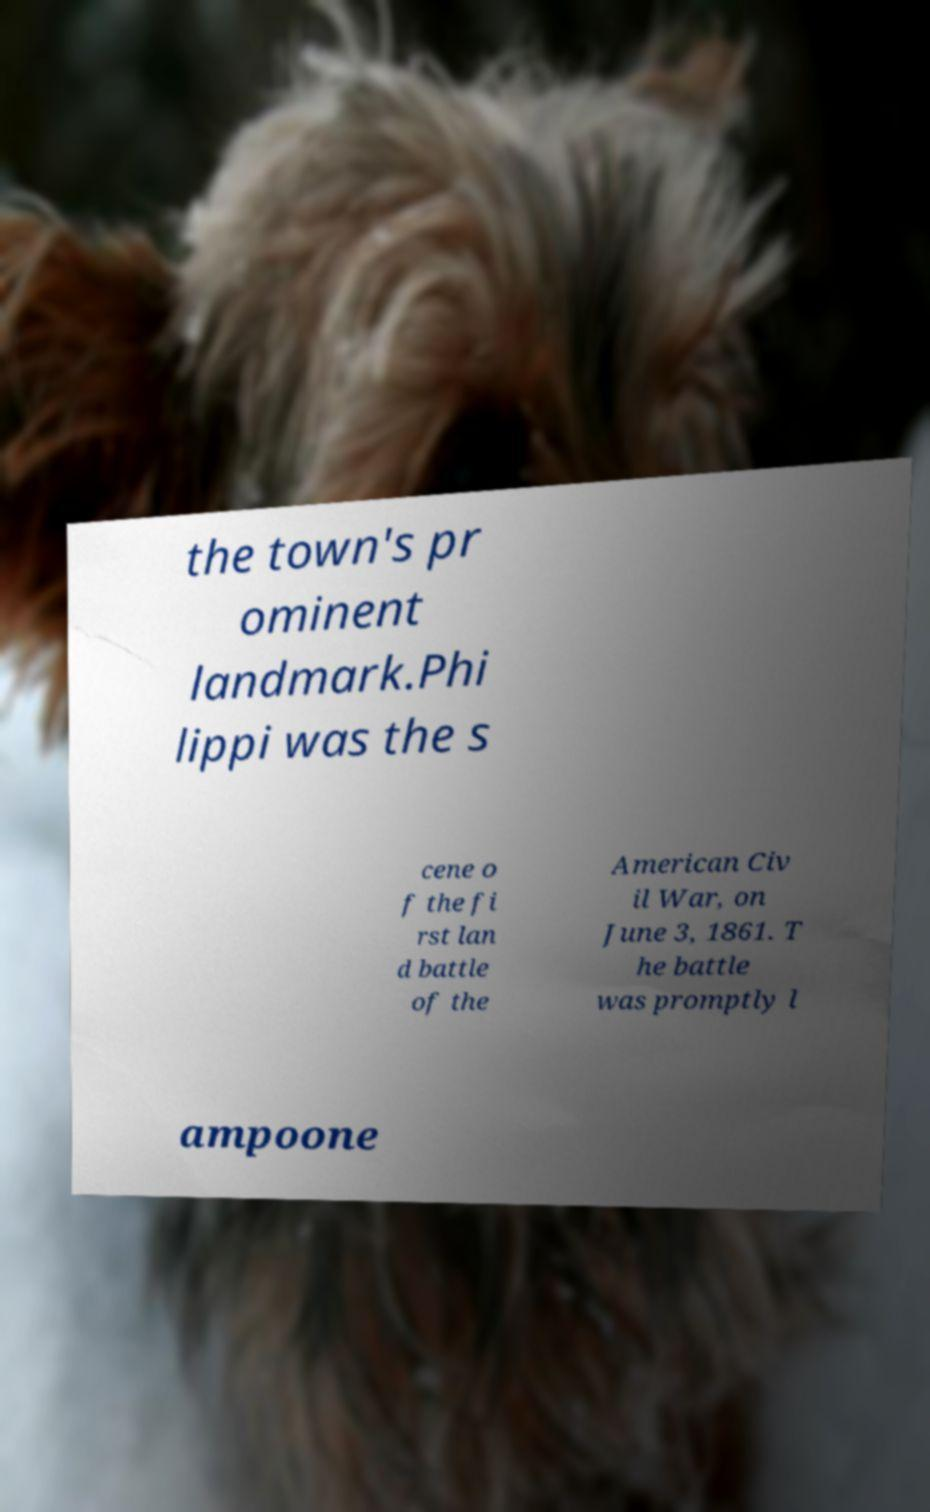For documentation purposes, I need the text within this image transcribed. Could you provide that? the town's pr ominent landmark.Phi lippi was the s cene o f the fi rst lan d battle of the American Civ il War, on June 3, 1861. T he battle was promptly l ampoone 